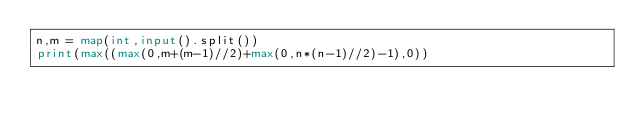<code> <loc_0><loc_0><loc_500><loc_500><_Python_>n,m = map(int,input().split())
print(max((max(0,m+(m-1)//2)+max(0,n*(n-1)//2)-1),0))</code> 